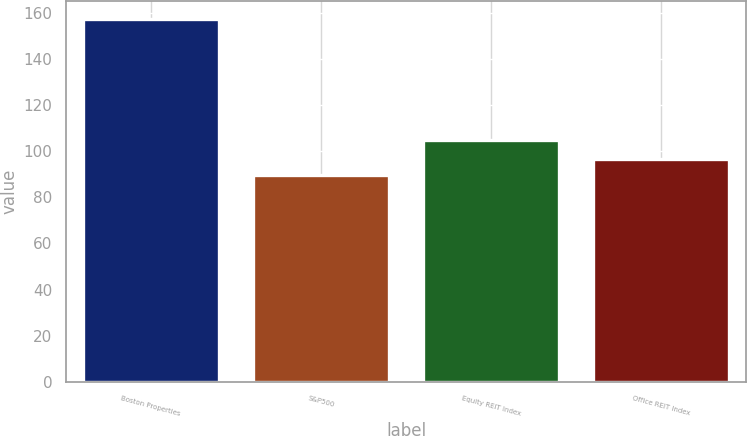Convert chart. <chart><loc_0><loc_0><loc_500><loc_500><bar_chart><fcel>Boston Properties<fcel>S&P500<fcel>Equity REIT Index<fcel>Office REIT Index<nl><fcel>157.2<fcel>89.52<fcel>104.65<fcel>96.72<nl></chart> 